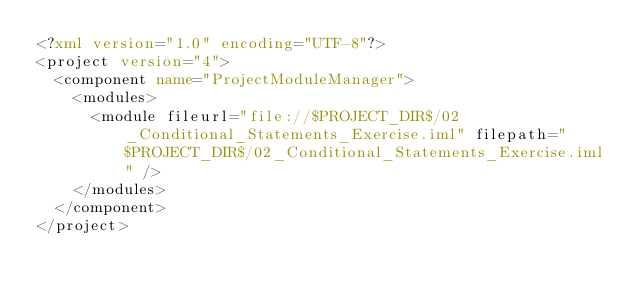Convert code to text. <code><loc_0><loc_0><loc_500><loc_500><_XML_><?xml version="1.0" encoding="UTF-8"?>
<project version="4">
  <component name="ProjectModuleManager">
    <modules>
      <module fileurl="file://$PROJECT_DIR$/02_Conditional_Statements_Exercise.iml" filepath="$PROJECT_DIR$/02_Conditional_Statements_Exercise.iml" />
    </modules>
  </component>
</project></code> 